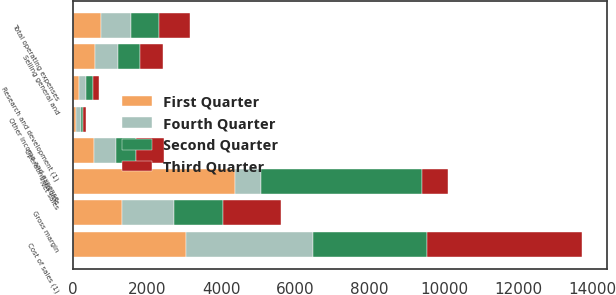Convert chart. <chart><loc_0><loc_0><loc_500><loc_500><stacked_bar_chart><ecel><fcel>Net sales<fcel>Cost of sales (1)<fcel>Gross margin<fcel>Research and development (1)<fcel>Selling general and<fcel>Total operating expenses<fcel>Operating income<fcel>Other income and expense<nl><fcel>Fourth Quarter<fcel>691<fcel>3425<fcel>1412<fcel>179<fcel>625<fcel>804<fcel>608<fcel>113<nl><fcel>First Quarter<fcel>4370<fcel>3045<fcel>1325<fcel>175<fcel>584<fcel>759<fcel>566<fcel>95<nl><fcel>Second Quarter<fcel>4359<fcel>3062<fcel>1297<fcel>176<fcel>592<fcel>768<fcel>529<fcel>76<nl><fcel>Third Quarter<fcel>691<fcel>4185<fcel>1564<fcel>182<fcel>632<fcel>814<fcel>750<fcel>81<nl></chart> 